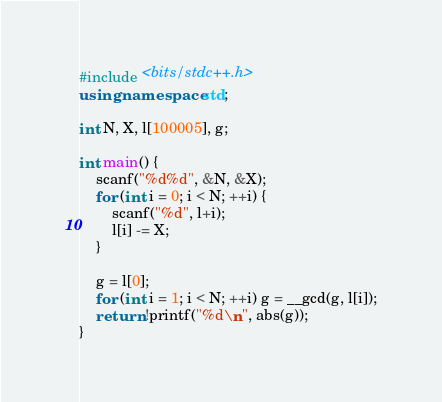<code> <loc_0><loc_0><loc_500><loc_500><_C++_>#include <bits/stdc++.h>
using namespace std;

int N, X, l[100005], g;

int main() {
    scanf("%d%d", &N, &X);
    for (int i = 0; i < N; ++i) {
        scanf("%d", l+i);
        l[i] -= X;
    }

    g = l[0];
    for (int i = 1; i < N; ++i) g = __gcd(g, l[i]);
    return !printf("%d\n", abs(g));
}</code> 